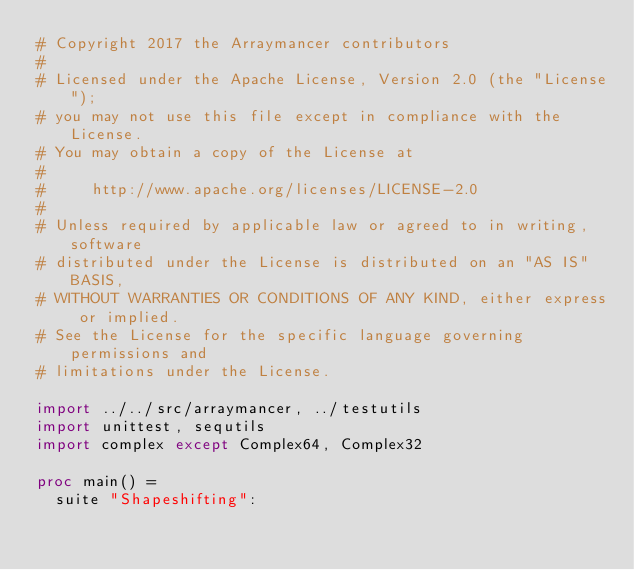Convert code to text. <code><loc_0><loc_0><loc_500><loc_500><_Nim_># Copyright 2017 the Arraymancer contributors
#
# Licensed under the Apache License, Version 2.0 (the "License");
# you may not use this file except in compliance with the License.
# You may obtain a copy of the License at
#
#     http://www.apache.org/licenses/LICENSE-2.0
#
# Unless required by applicable law or agreed to in writing, software
# distributed under the License is distributed on an "AS IS" BASIS,
# WITHOUT WARRANTIES OR CONDITIONS OF ANY KIND, either express or implied.
# See the License for the specific language governing permissions and
# limitations under the License.

import ../../src/arraymancer, ../testutils
import unittest, sequtils
import complex except Complex64, Complex32

proc main() =
  suite "Shapeshifting":</code> 